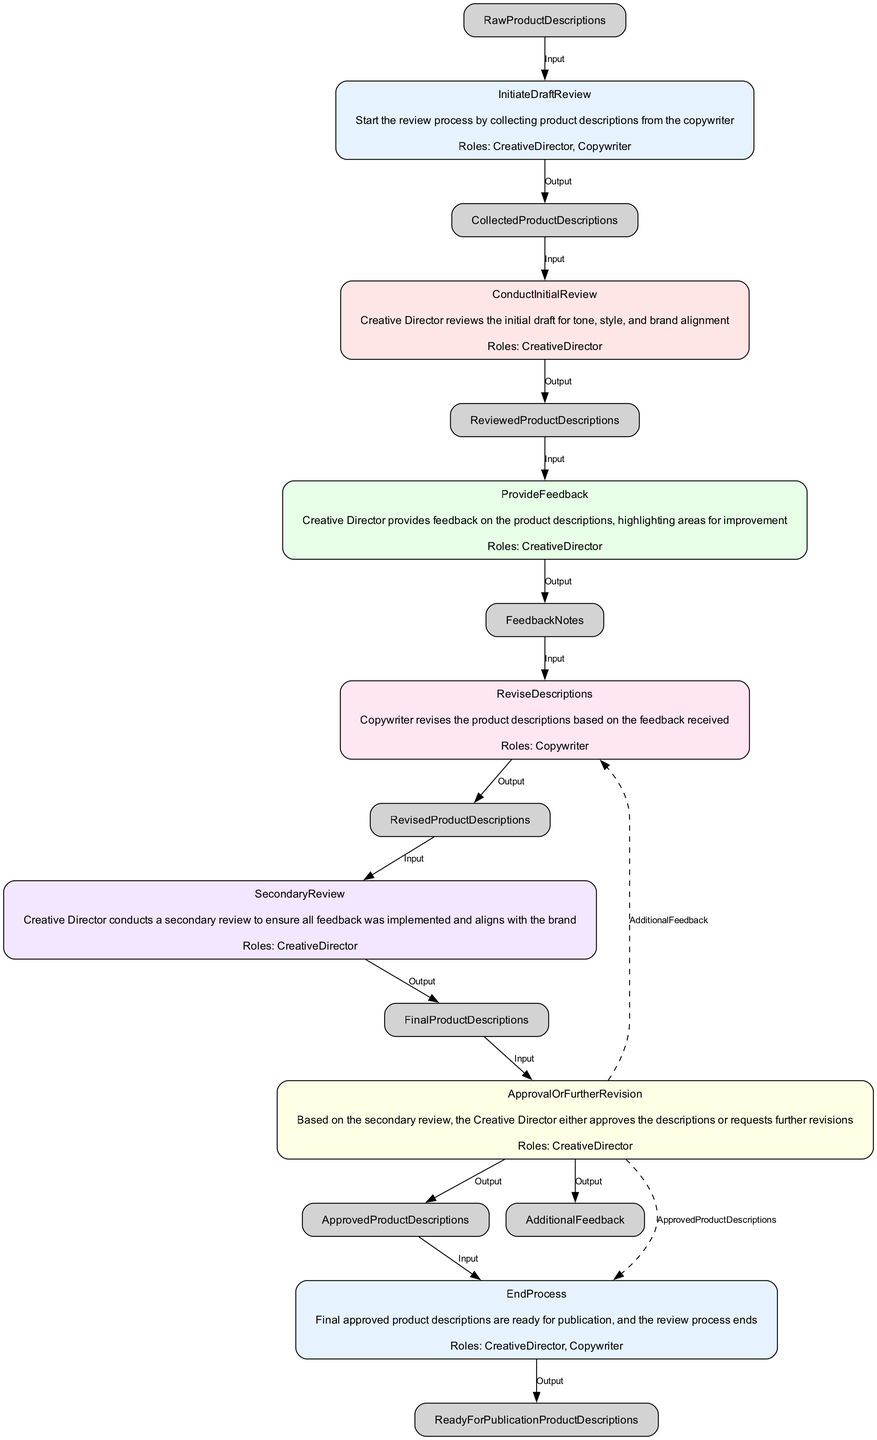What is the first function in the diagram? The first function in the diagram is labeled "InitiateDraftReview." It initiates the review process by collecting product descriptions from the copywriter.
Answer: InitiateDraftReview How many roles are involved in the "ConductInitialReview"? The "ConductInitialReview" function involves only one role, which is the Creative Director, who performs the review of the descriptions.
Answer: One What is the output of the "ProvideFeedback" function? The output of the "ProvideFeedback" function is "FeedbackNotes." This represents the notes made by the Creative Director for improving the product descriptions.
Answer: FeedbackNotes Which function follows "ReviseDescriptions"? The function that follows "ReviseDescriptions" is "SecondaryReview." This indicates the next step after the Copywriter revises the descriptions based on the feedback.
Answer: SecondaryReview What decision is made in the "ApprovalOrFurtherRevision" function? In the "ApprovalOrFurtherRevision" function, the Creative Director decides either to approve the descriptions or request additional feedback for further revisions, creating a decision point in the process.
Answer: Approve or AdditionalFeedback How many total functions are represented in the flowchart? The flowchart contains a total of six distinct functions, each representing a different step in the feedback and refinement process for product descriptions.
Answer: Six What roles are involved in the final process? The final process, "EndProcess," involves both the Creative Director and the Copywriter. This indicates collaborative effort at the final stage for publication readiness.
Answer: CreativeDirector, Copywriter What is the main purpose of the "SecondaryReview" function? The purpose of the "SecondaryReview" function is to ensure that the revisions made by the Copywriter are in alignment with the feedback given and the overall brand.
Answer: Ensure alignment What happens if the product descriptions get additional feedback? If the product descriptions receive additional feedback, the process directs back to the "ReviseDescriptions" function, prompting the Copywriter to make further adjustments as necessary.
Answer: ReviseDescriptions 